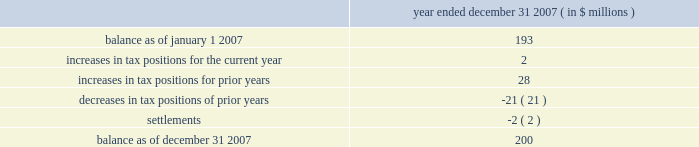Determined that it will primarily be subject to the ietu in future periods , and as such it has recorded tax expense of approximately $ 20 million in 2007 for the deferred tax effects of the new ietu system .
As of december 31 , 2007 , the company had us federal net operating loss carryforwards of approximately $ 206 million which will begin to expire in 2023 .
Of this amount , $ 47 million relates to the pre-acquisition period and is subject to limitation .
The remaining $ 159 million is subject to limitation as a result of the change in stock ownership in may 2006 .
This limitation is not expected to have a material impact on utilization of the net operating loss carryforwards .
The company also had foreign net operating loss carryforwards as of december 31 , 2007 of approximately $ 564 million for canada , germany , mexico and other foreign jurisdictions with various expiration dates .
Net operating losses in canada have various carryforward periods and began expiring in 2007 .
Net operating losses in germany have no expiration date .
Net operating losses in mexico have a ten year carryforward period and begin to expire in 2009 .
However , these losses are not available for use under the new ietu tax regulations in mexico .
As the ietu is the primary system upon which the company will be subject to tax in future periods , no deferred tax asset has been reflected in the balance sheet as of december 31 , 2007 for these income tax loss carryforwards .
The company adopted the provisions of fin 48 effective january 1 , 2007 .
Fin 48 clarifies the accounting for income taxes by prescribing a minimum recognition threshold a tax benefit is required to meet before being recognized in the financial statements .
Fin 48 also provides guidance on derecognition , measurement , classification , interest and penalties , accounting in interim periods , disclosure and transition .
As a result of the implementation of fin 48 , the company increased retained earnings by $ 14 million and decreased goodwill by $ 2 million .
In addition , certain tax liabilities for unrecognized tax benefits , as well as related potential penalties and interest , were reclassified from current liabilities to long-term liabilities .
Liabilities for unrecognized tax benefits as of december 31 , 2007 relate to various us and foreign jurisdictions .
A reconciliation of the beginning and ending amount of unrecognized tax benefits is as follows : year ended december 31 , 2007 ( in $ millions ) .
Included in the unrecognized tax benefits of $ 200 million as of december 31 , 2007 is $ 56 million of tax benefits that , if recognized , would reduce the company 2019s effective tax rate .
The company recognizes interest and penalties related to unrecognized tax benefits in the provision for income taxes .
As of december 31 , 2007 , the company has recorded a liability of approximately $ 36 million for interest and penalties .
This amount includes an increase of approximately $ 13 million for the year ended december 31 , 2007 .
The company operates in the united states ( including multiple state jurisdictions ) , germany and approximately 40 other foreign jurisdictions including canada , china , france , mexico and singapore .
Examinations are ongoing in a number of those jurisdictions including , most significantly , in germany for the years 2001 to 2004 .
During the quarter ended march 31 , 2007 , the company received final assessments in germany for the prior examination period , 1997 to 2000 .
The effective settlement of those examinations resulted in a reduction to goodwill of approximately $ 42 million with a net expected cash outlay of $ 29 million .
The company 2019s celanese corporation and subsidiaries notes to consolidated financial statements 2014 ( continued ) %%transmsg*** transmitting job : y48011 pcn : 122000000 ***%%pcmsg|f-49 |00023|yes|no|02/26/2008 22:07|0|0|page is valid , no graphics -- color : d| .
In 2007 what was the percentage change in the account balance of unrecognized tax benefits based on the reconciliation at december 31 .? 
Computations: ((2000 - 193) / 193)
Answer: 9.36269. 